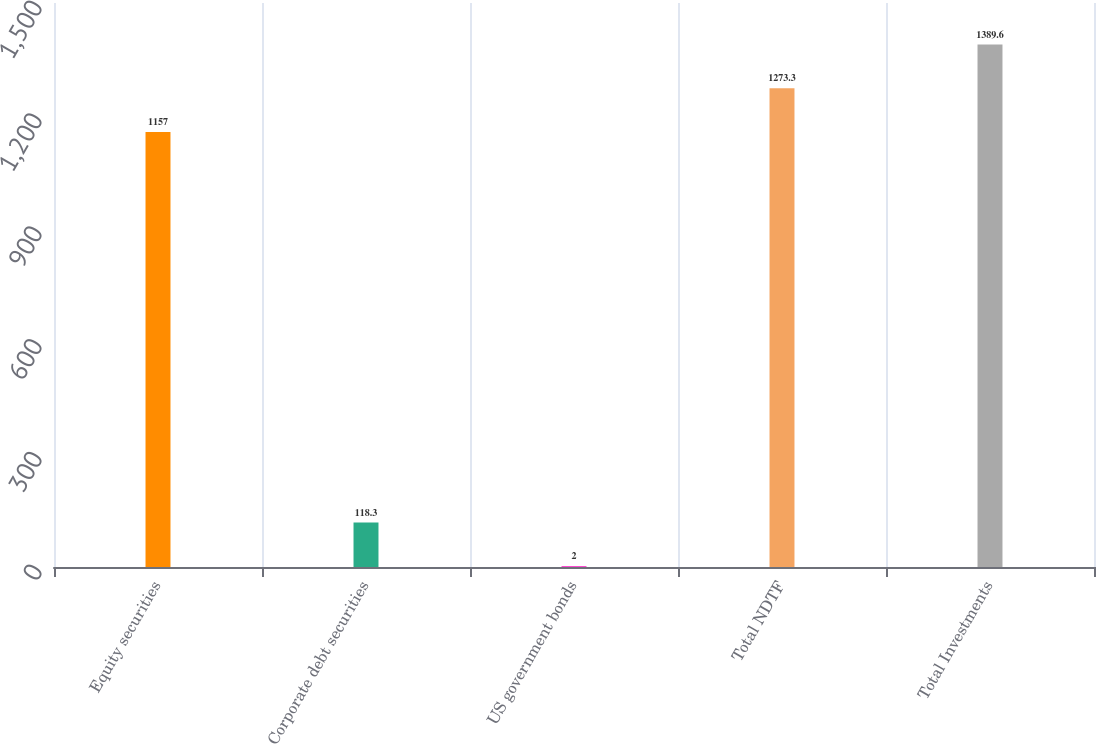Convert chart to OTSL. <chart><loc_0><loc_0><loc_500><loc_500><bar_chart><fcel>Equity securities<fcel>Corporate debt securities<fcel>US government bonds<fcel>Total NDTF<fcel>Total Investments<nl><fcel>1157<fcel>118.3<fcel>2<fcel>1273.3<fcel>1389.6<nl></chart> 